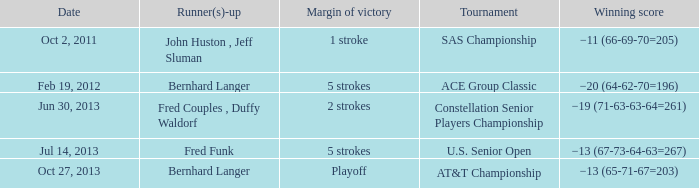Which Tournament has a Date of jul 14, 2013? U.S. Senior Open. 